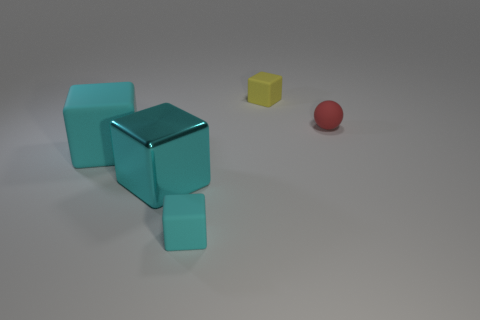There is a shiny block that is on the right side of the big cyan thing to the left of the metal block; what is its size?
Ensure brevity in your answer.  Large. Is the tiny block that is behind the tiny red rubber object made of the same material as the small block that is in front of the small matte ball?
Your answer should be compact. Yes. Is there a large block of the same color as the large shiny object?
Offer a terse response. Yes. There is a rubber block that is the same size as the shiny object; what is its color?
Your answer should be very brief. Cyan. There is a matte object that is left of the small cyan matte thing; is its color the same as the large metal thing?
Give a very brief answer. Yes. The tiny matte thing that is the same color as the metal block is what shape?
Provide a short and direct response. Cube. There is another cyan thing that is made of the same material as the small cyan object; what size is it?
Give a very brief answer. Large. Is the color of the big metallic block the same as the big matte block?
Your answer should be compact. Yes. There is a tiny thing that is in front of the large shiny cube; does it have the same shape as the cyan shiny object that is in front of the small yellow cube?
Keep it short and to the point. Yes. There is a small yellow thing that is the same shape as the tiny cyan rubber object; what is its material?
Ensure brevity in your answer.  Rubber. 